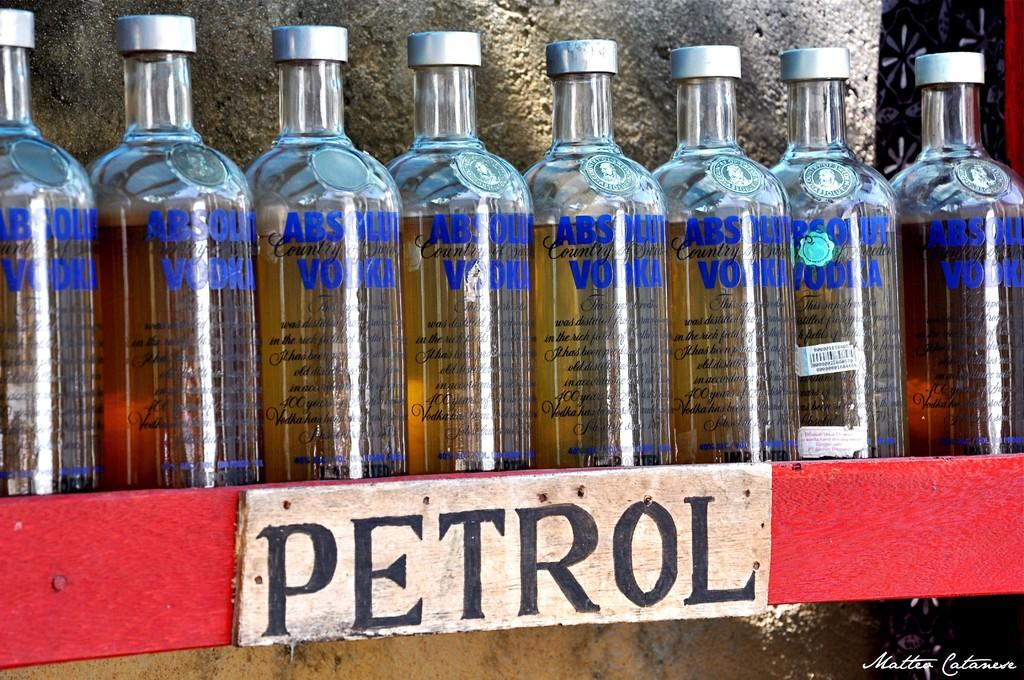<image>
Render a clear and concise summary of the photo. A row of eight Absolut vodka bottles lined up on a red shelf. 